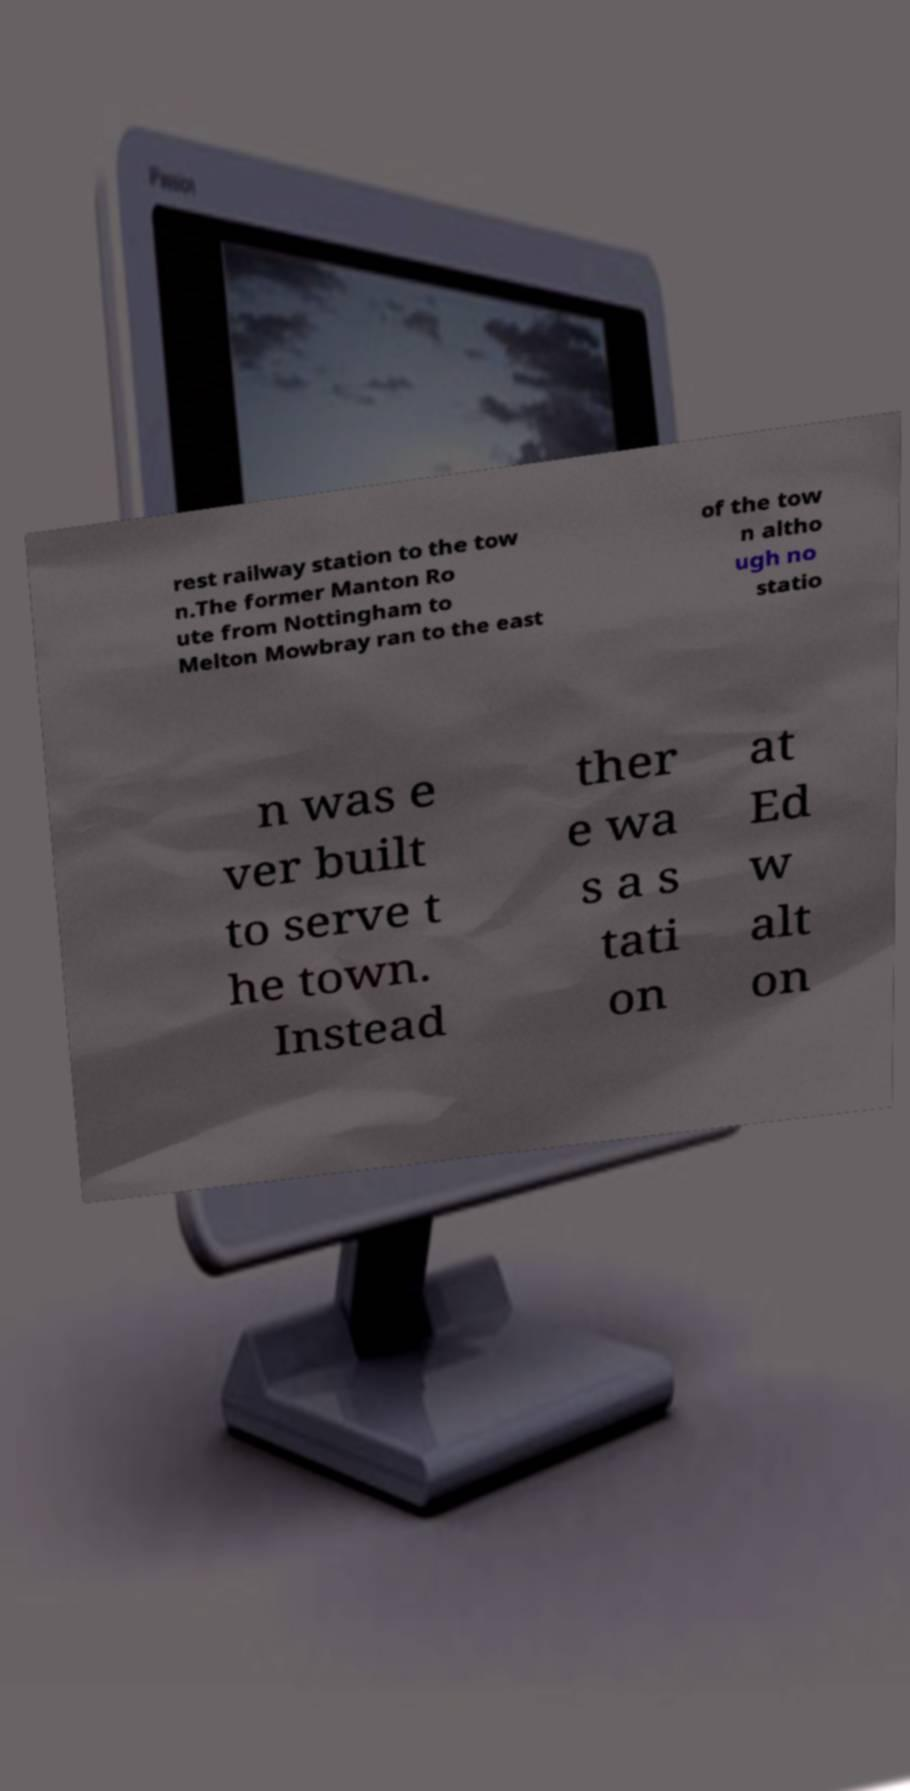Please identify and transcribe the text found in this image. rest railway station to the tow n.The former Manton Ro ute from Nottingham to Melton Mowbray ran to the east of the tow n altho ugh no statio n was e ver built to serve t he town. Instead ther e wa s a s tati on at Ed w alt on 